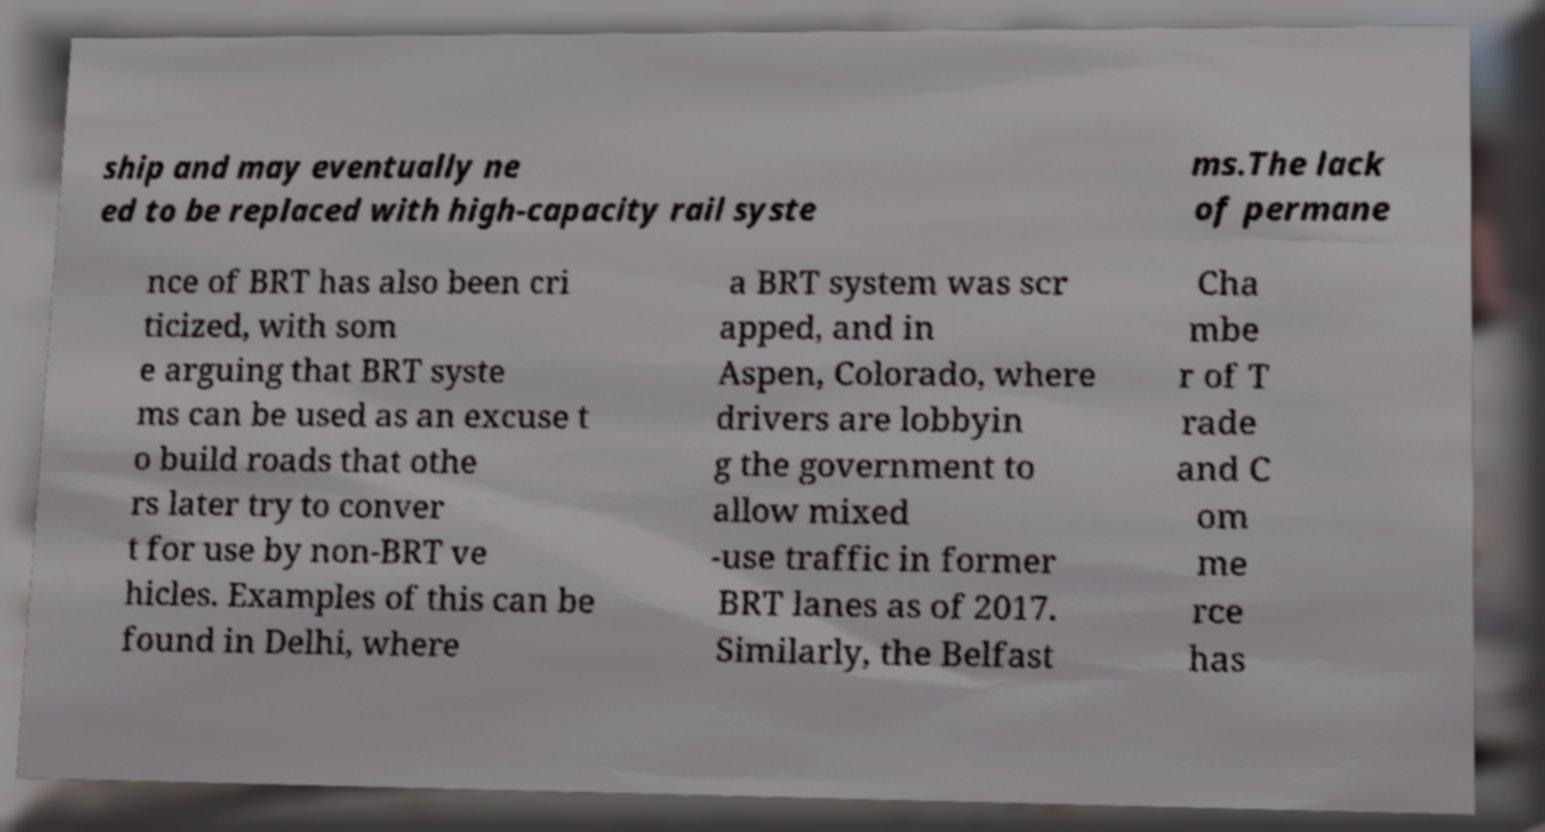I need the written content from this picture converted into text. Can you do that? ship and may eventually ne ed to be replaced with high-capacity rail syste ms.The lack of permane nce of BRT has also been cri ticized, with som e arguing that BRT syste ms can be used as an excuse t o build roads that othe rs later try to conver t for use by non-BRT ve hicles. Examples of this can be found in Delhi, where a BRT system was scr apped, and in Aspen, Colorado, where drivers are lobbyin g the government to allow mixed -use traffic in former BRT lanes as of 2017. Similarly, the Belfast Cha mbe r of T rade and C om me rce has 